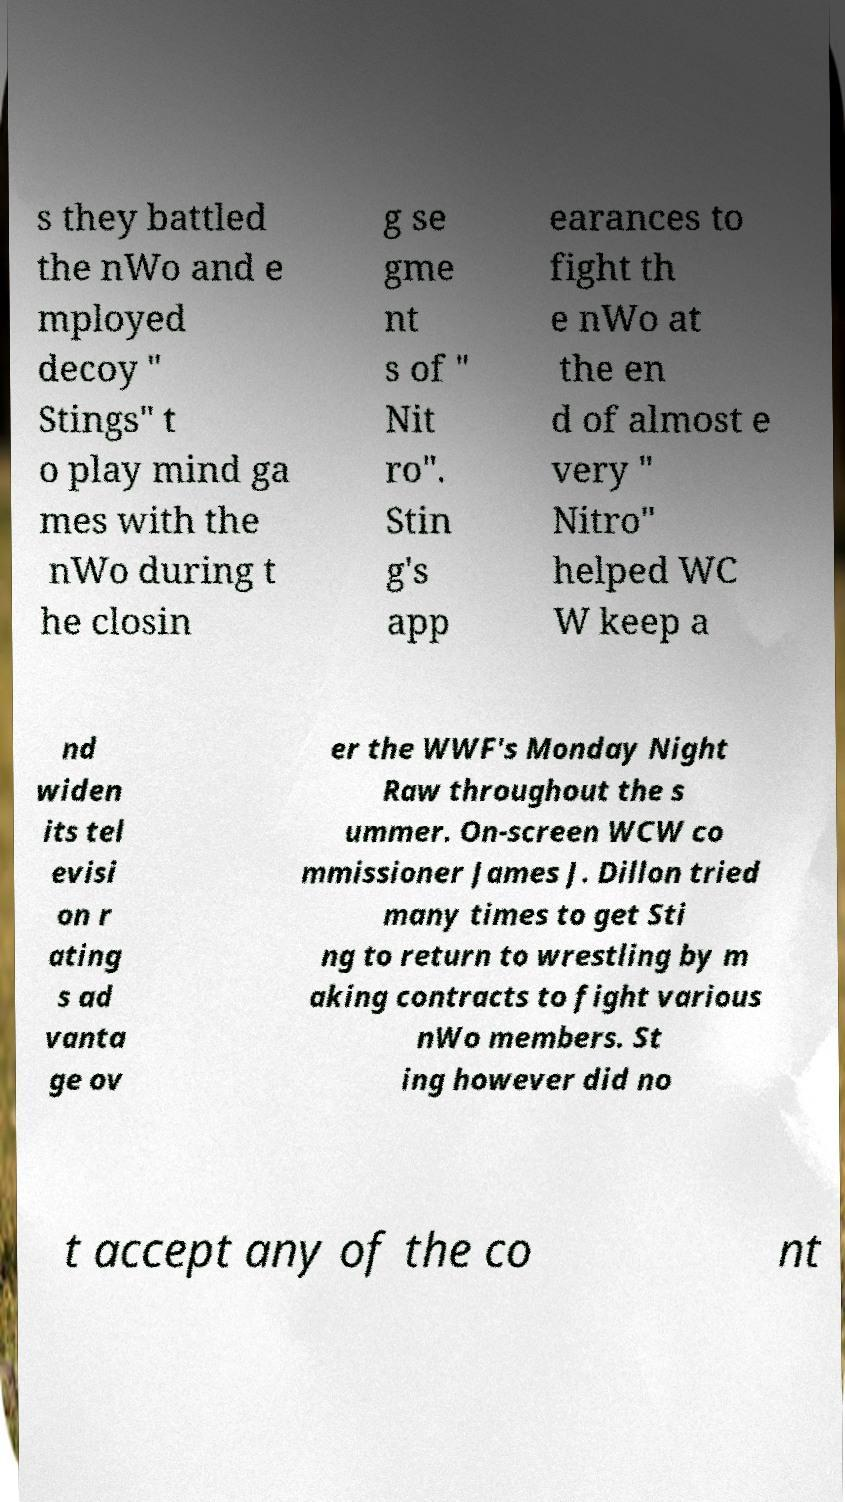Can you accurately transcribe the text from the provided image for me? s they battled the nWo and e mployed decoy " Stings" t o play mind ga mes with the nWo during t he closin g se gme nt s of " Nit ro". Stin g's app earances to fight th e nWo at the en d of almost e very " Nitro" helped WC W keep a nd widen its tel evisi on r ating s ad vanta ge ov er the WWF's Monday Night Raw throughout the s ummer. On-screen WCW co mmissioner James J. Dillon tried many times to get Sti ng to return to wrestling by m aking contracts to fight various nWo members. St ing however did no t accept any of the co nt 